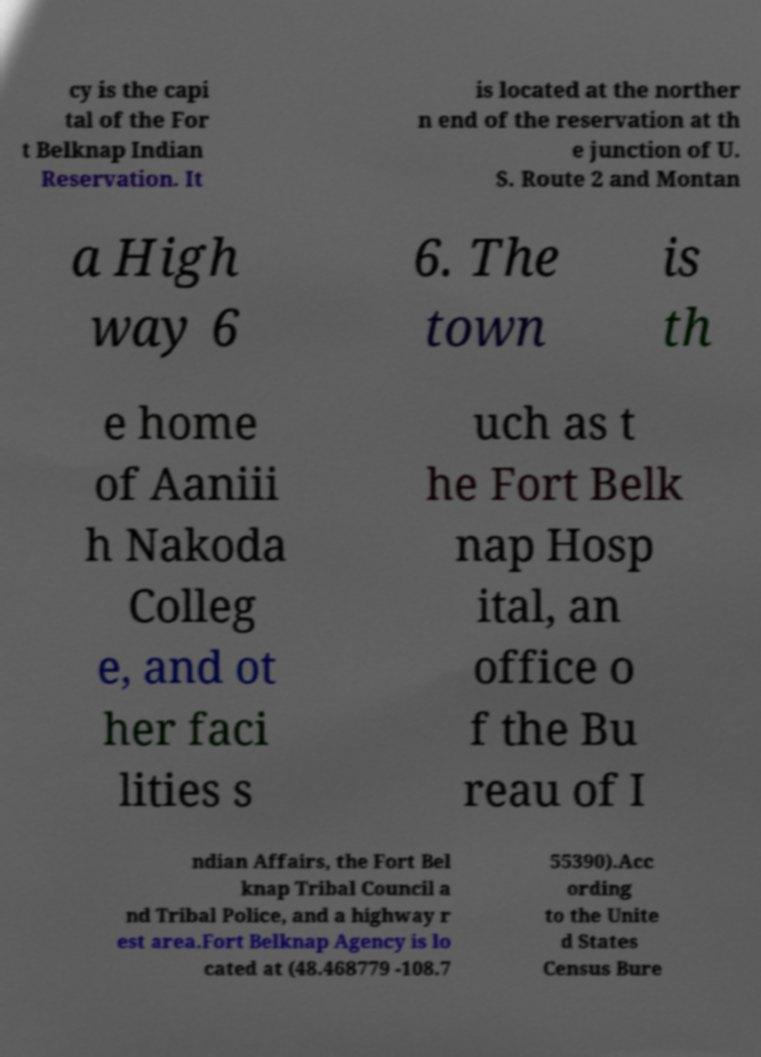Please identify and transcribe the text found in this image. cy is the capi tal of the For t Belknap Indian Reservation. It is located at the norther n end of the reservation at th e junction of U. S. Route 2 and Montan a High way 6 6. The town is th e home of Aaniii h Nakoda Colleg e, and ot her faci lities s uch as t he Fort Belk nap Hosp ital, an office o f the Bu reau of I ndian Affairs, the Fort Bel knap Tribal Council a nd Tribal Police, and a highway r est area.Fort Belknap Agency is lo cated at (48.468779 -108.7 55390).Acc ording to the Unite d States Census Bure 